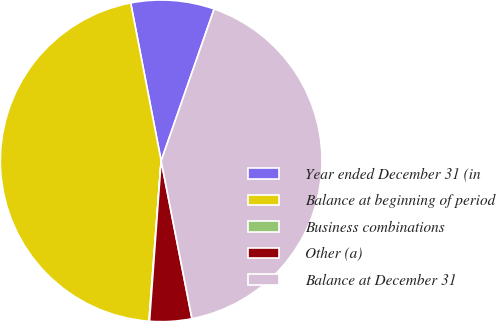Convert chart. <chart><loc_0><loc_0><loc_500><loc_500><pie_chart><fcel>Year ended December 31 (in<fcel>Balance at beginning of period<fcel>Business combinations<fcel>Other (a)<fcel>Balance at December 31<nl><fcel>8.38%<fcel>45.76%<fcel>0.06%<fcel>4.22%<fcel>41.59%<nl></chart> 